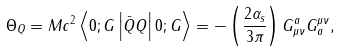<formula> <loc_0><loc_0><loc_500><loc_500>\Theta _ { Q } = M c ^ { 2 } \left < 0 ; G \left | \bar { Q } Q \right | 0 ; G \right > = - \left ( \frac { 2 \alpha _ { s } } { 3 \pi } \right ) G ^ { a } _ { \mu \nu } G _ { a } ^ { \mu \nu } ,</formula> 